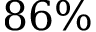<formula> <loc_0><loc_0><loc_500><loc_500>8 6 \%</formula> 